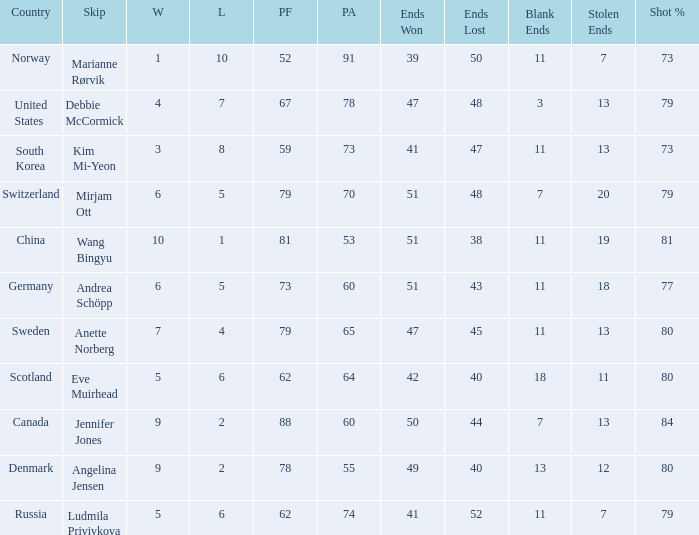When the country was Scotland, how many ends were won? 1.0. 